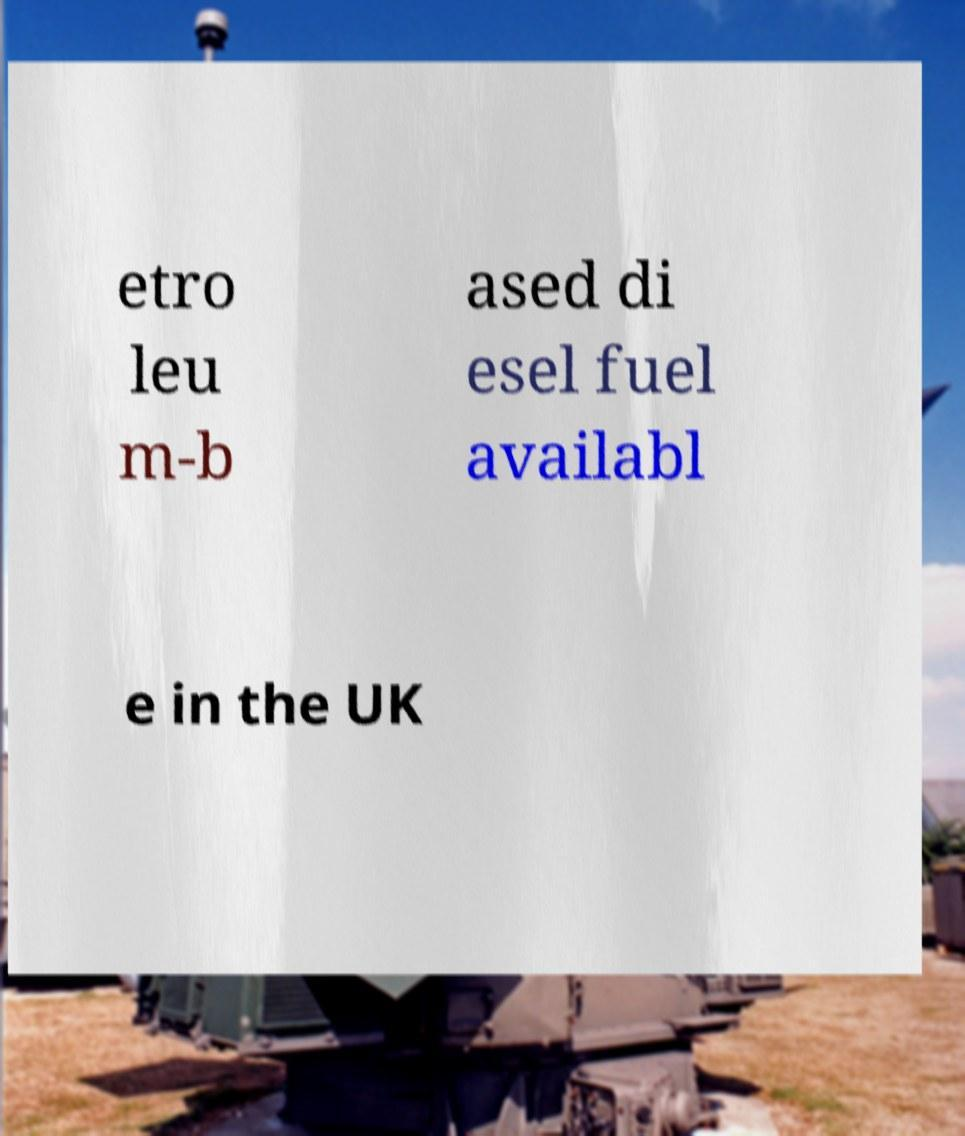Please read and relay the text visible in this image. What does it say? etro leu m-b ased di esel fuel availabl e in the UK 